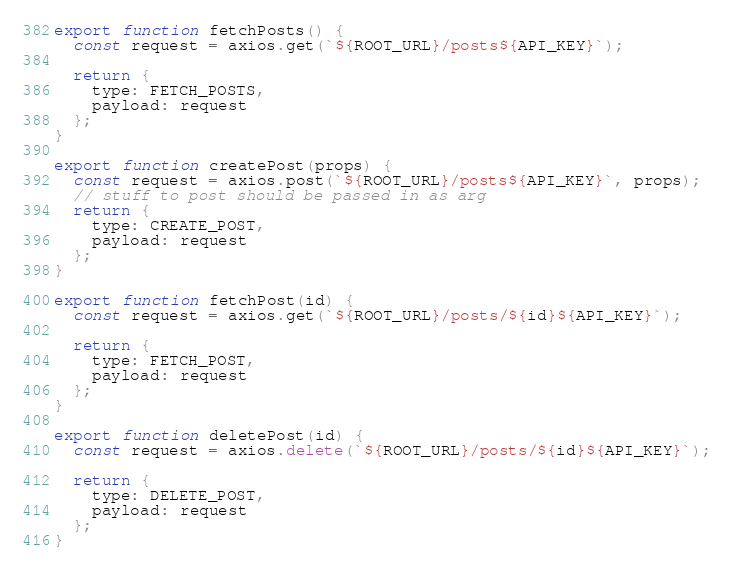Convert code to text. <code><loc_0><loc_0><loc_500><loc_500><_JavaScript_>export function fetchPosts() {
  const request = axios.get(`${ROOT_URL}/posts${API_KEY}`);

  return {
    type: FETCH_POSTS,
    payload: request
  };
}

export function createPost(props) {
  const request = axios.post(`${ROOT_URL}/posts${API_KEY}`, props);
  // stuff to post should be passed in as arg
  return {
    type: CREATE_POST,
    payload: request
  };
}

export function fetchPost(id) {
  const request = axios.get(`${ROOT_URL}/posts/${id}${API_KEY}`);

  return {
    type: FETCH_POST,
    payload: request
  };
}

export function deletePost(id) {
  const request = axios.delete(`${ROOT_URL}/posts/${id}${API_KEY}`);

  return {
    type: DELETE_POST,
    payload: request
  };
}
</code> 